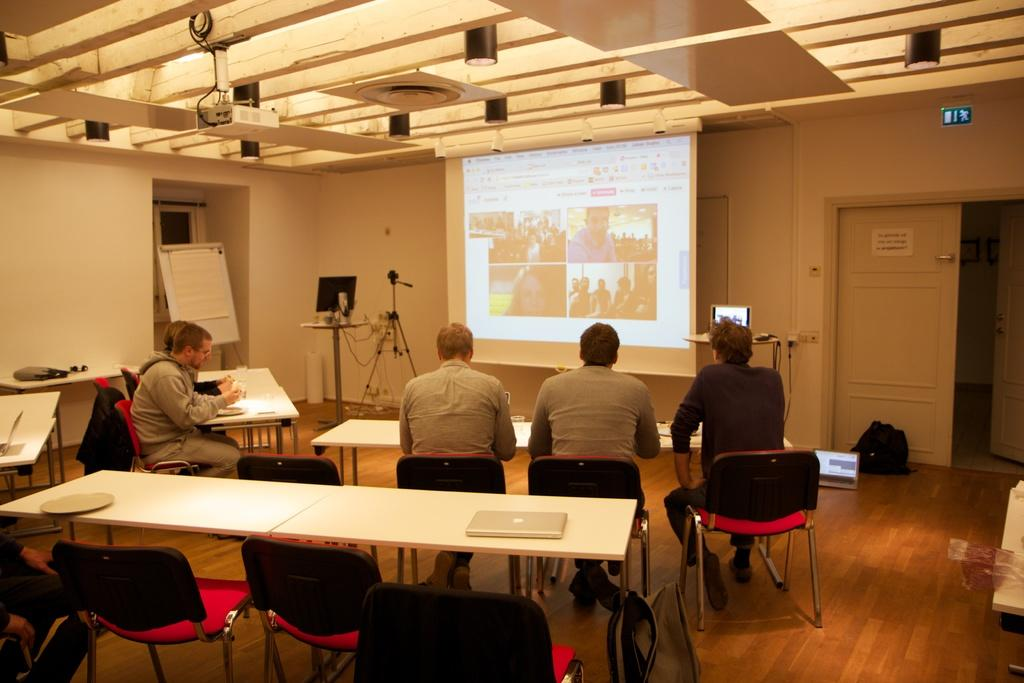Who is present in the image? There are people in the image. What are the people doing in the image? The people are watching a presentation. How is the presentation being displayed? The presentation is displayed on a screen. What type of spark can be seen coming from the cake in the image? There is no cake or spark present in the image; the people are watching a presentation displayed on a screen. 